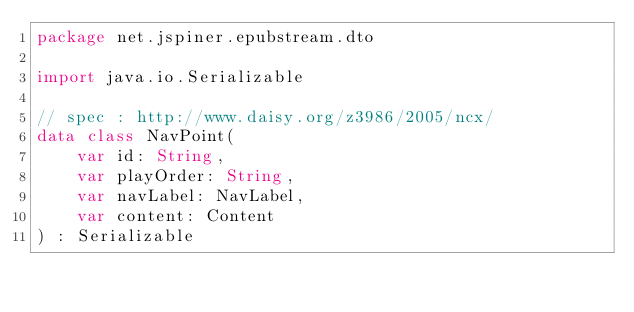<code> <loc_0><loc_0><loc_500><loc_500><_Kotlin_>package net.jspiner.epubstream.dto

import java.io.Serializable

// spec : http://www.daisy.org/z3986/2005/ncx/
data class NavPoint(
    var id: String,
    var playOrder: String,
    var navLabel: NavLabel,
    var content: Content
) : Serializable</code> 